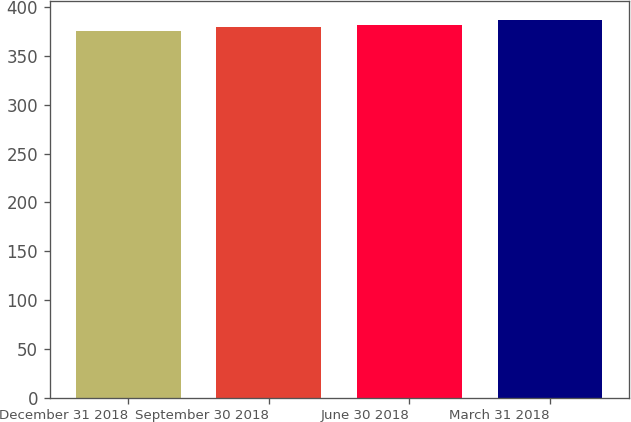Convert chart. <chart><loc_0><loc_0><loc_500><loc_500><bar_chart><fcel>December 31 2018<fcel>September 30 2018<fcel>June 30 2018<fcel>March 31 2018<nl><fcel>376<fcel>380<fcel>382<fcel>387<nl></chart> 